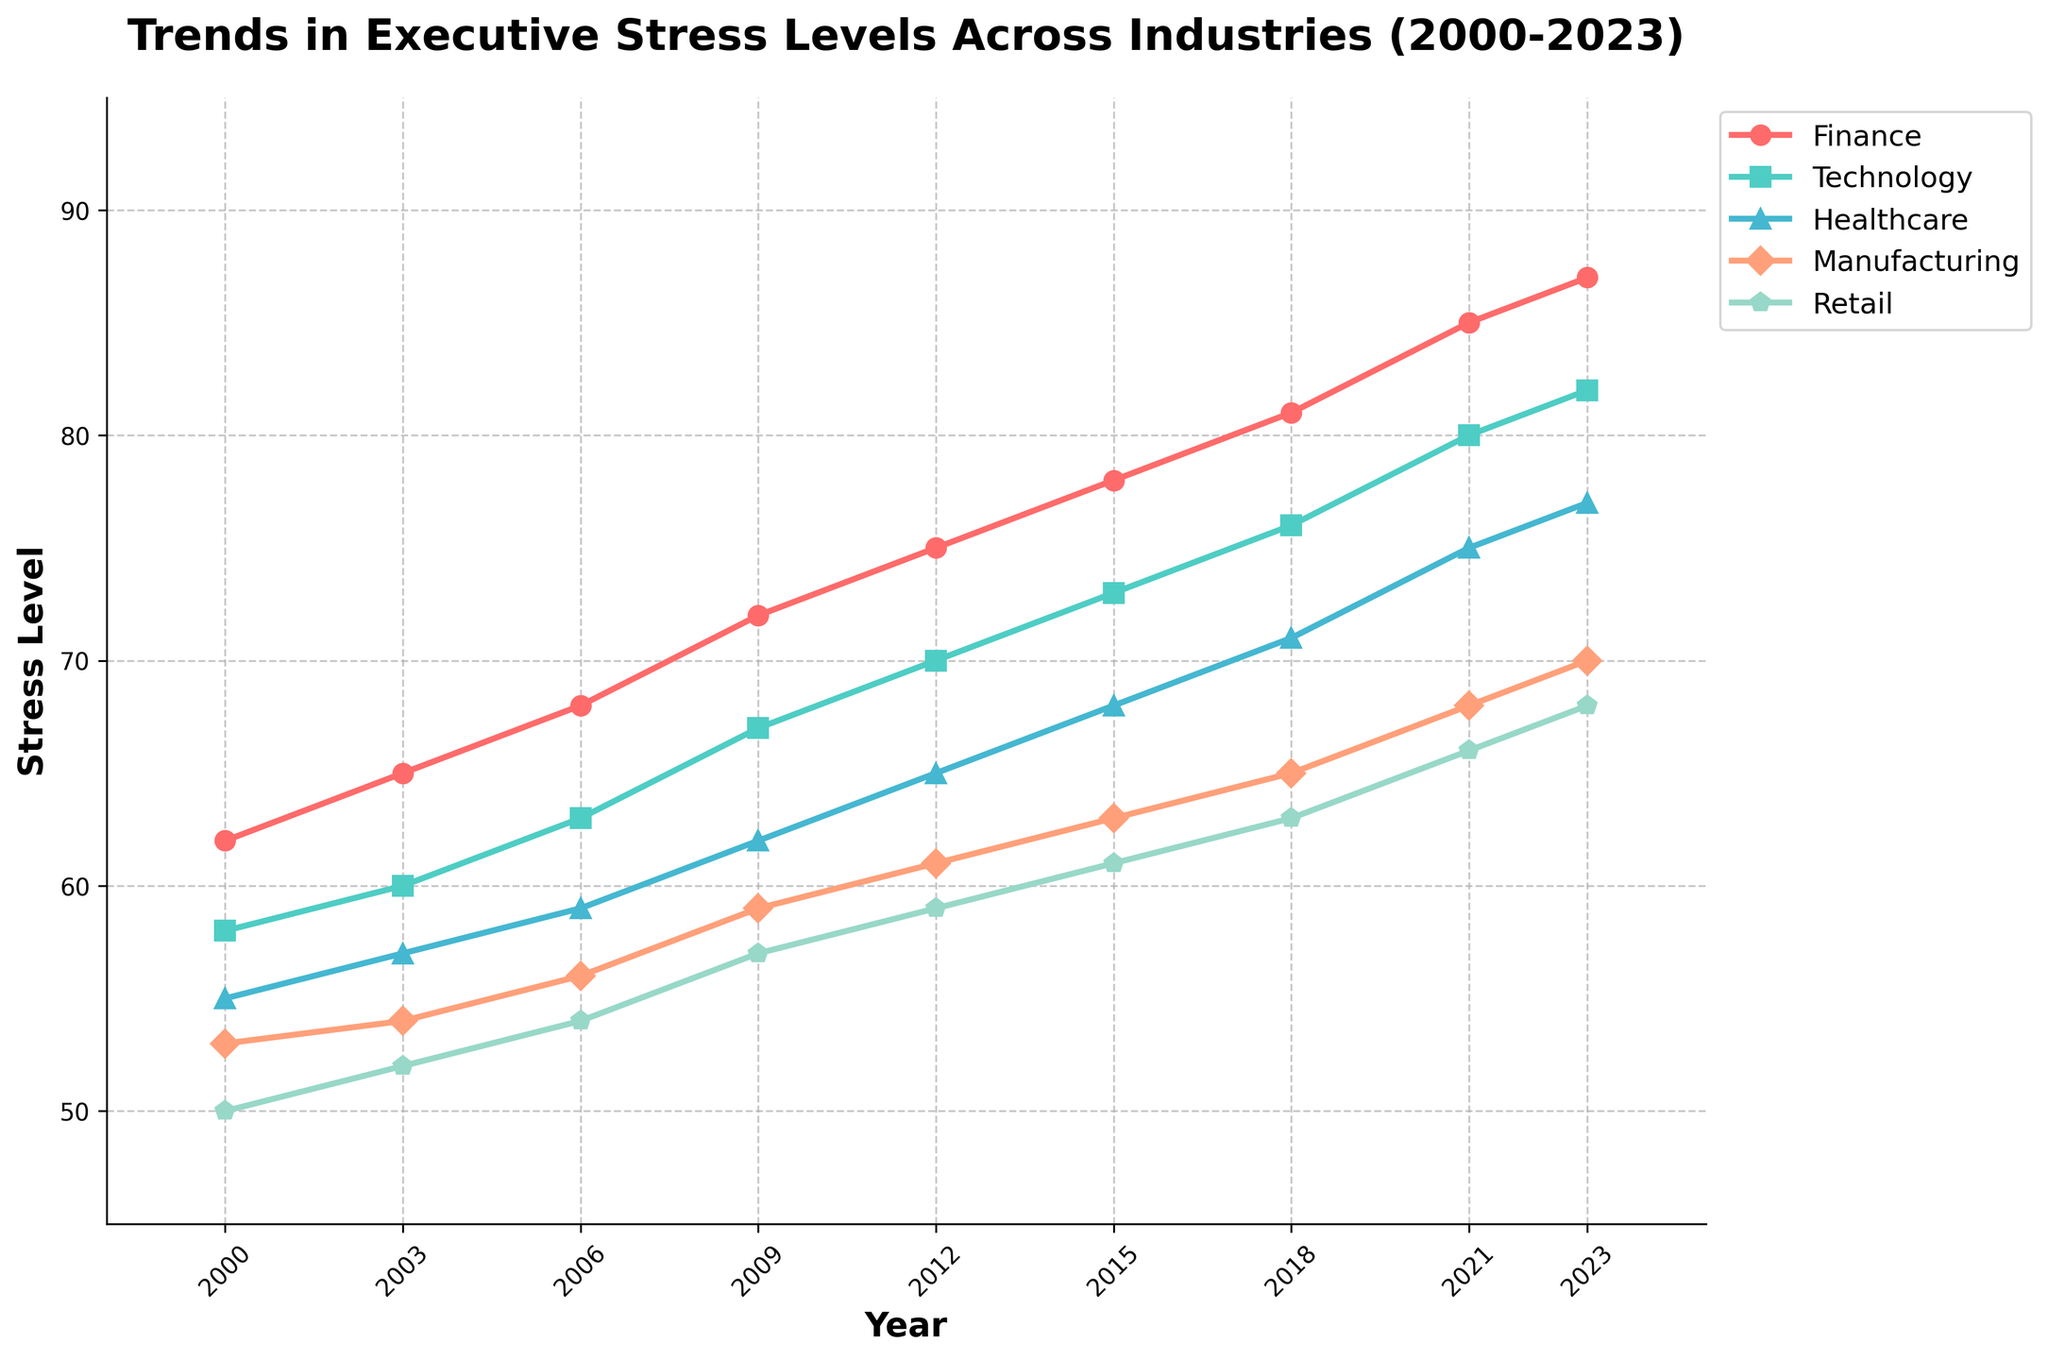Which industry has the highest executive stress level in 2023? By observing the plot, we see that the Finance industry line reaches the highest point on the y-axis in 2023.
Answer: Finance Between 2000 and 2023, in which year did the Healthcare industry experience the largest increase in stress level compared to the previous year? We need to look at the difference between consecutive years for the Healthcare line. The largest increase occurs between 2006 and 2009, where the stress level increases from 59 to 62.
Answer: 2009 How much did the stress level in Manufacturing increase from 2000 to 2023? Subtract the Manufacturing stress level in 2000 from the level in 2023: 70 - 53 = 17.
Answer: 17 On average, how did stress levels change in the Retail industry every three years from 2000 to 2023? Calculate the average change: (52-50)/3, (54-52)/3, (57-54)/3, (59-57)/3, (61-59)/3, (63-61)/3, (66-63)/3, (68-66)/3. The consistent rate of change is approximately 2.
Answer: 2 (approximately) Which industry had the lowest stress level in 2018? By examining the data points for 2018, the Retail industry had the lowest stress level at 63.
Answer: Retail Compare the stress level trend in Finance and Technology from 2000 to 2023; which industry had a greater cumulative increase over this period? By calculating the cumulative increase for both: Finance (87-62=25), Technology (82-58=24). Finance shows a greater cumulative increase.
Answer: Finance What is the difference in stress levels between Technology and Retail in 2023? Subtract the stress level of Retail from Technology in 2023: 82 - 68 = 14.
Answer: 14 Did the Manufacturing industry ever surpass 70 in stress levels from 2000 to 2023? By referring to the Manufacturing line in the plot, we see that it only reached 70 in 2023 and never surpassed it.
Answer: No What is the average stress level of executives across all industries in 2021? Sum the stress levels of all industries in 2021 and divide by the number of industries: (85 + 80 + 75 + 68 + 66) / 5 = 74.8
Answer: 74.8 